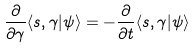Convert formula to latex. <formula><loc_0><loc_0><loc_500><loc_500>\frac { \partial } { \partial \gamma } \langle s , \gamma | \psi \rangle = - \frac { \partial } { \partial t } \langle s , \gamma | \psi \rangle</formula> 